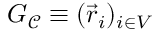Convert formula to latex. <formula><loc_0><loc_0><loc_500><loc_500>G _ { \mathcal { C } } \equiv ( \vec { r } _ { i } ) _ { i \in V }</formula> 